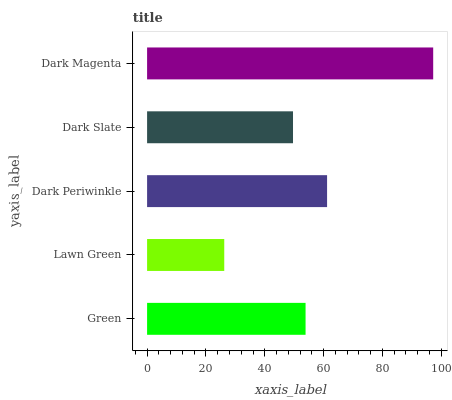Is Lawn Green the minimum?
Answer yes or no. Yes. Is Dark Magenta the maximum?
Answer yes or no. Yes. Is Dark Periwinkle the minimum?
Answer yes or no. No. Is Dark Periwinkle the maximum?
Answer yes or no. No. Is Dark Periwinkle greater than Lawn Green?
Answer yes or no. Yes. Is Lawn Green less than Dark Periwinkle?
Answer yes or no. Yes. Is Lawn Green greater than Dark Periwinkle?
Answer yes or no. No. Is Dark Periwinkle less than Lawn Green?
Answer yes or no. No. Is Green the high median?
Answer yes or no. Yes. Is Green the low median?
Answer yes or no. Yes. Is Lawn Green the high median?
Answer yes or no. No. Is Dark Slate the low median?
Answer yes or no. No. 